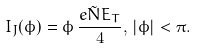Convert formula to latex. <formula><loc_0><loc_0><loc_500><loc_500>I _ { J } ( \phi ) = \phi \, \frac { e \tilde { N } E _ { T } } { 4 } , \, | \phi | < \pi .</formula> 